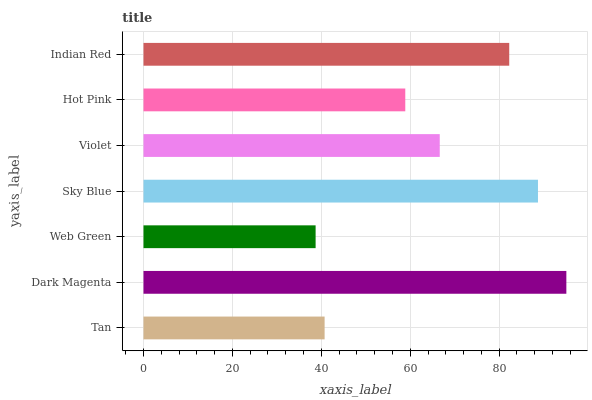Is Web Green the minimum?
Answer yes or no. Yes. Is Dark Magenta the maximum?
Answer yes or no. Yes. Is Dark Magenta the minimum?
Answer yes or no. No. Is Web Green the maximum?
Answer yes or no. No. Is Dark Magenta greater than Web Green?
Answer yes or no. Yes. Is Web Green less than Dark Magenta?
Answer yes or no. Yes. Is Web Green greater than Dark Magenta?
Answer yes or no. No. Is Dark Magenta less than Web Green?
Answer yes or no. No. Is Violet the high median?
Answer yes or no. Yes. Is Violet the low median?
Answer yes or no. Yes. Is Sky Blue the high median?
Answer yes or no. No. Is Indian Red the low median?
Answer yes or no. No. 